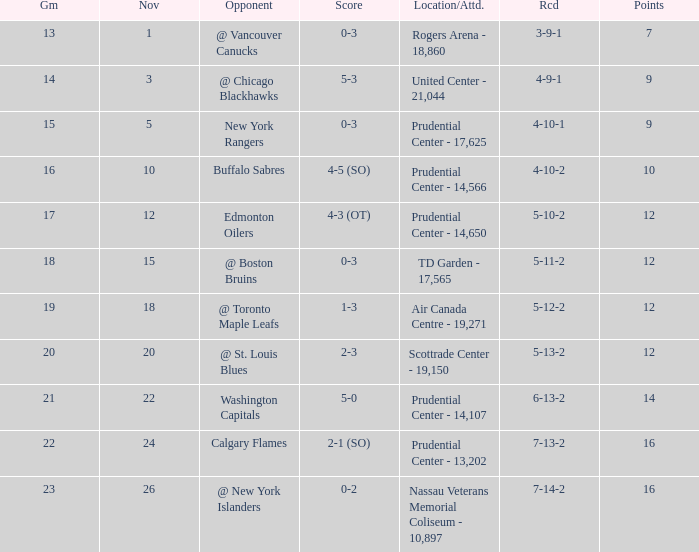Who was the opponent where the game is 14? @ Chicago Blackhawks. 